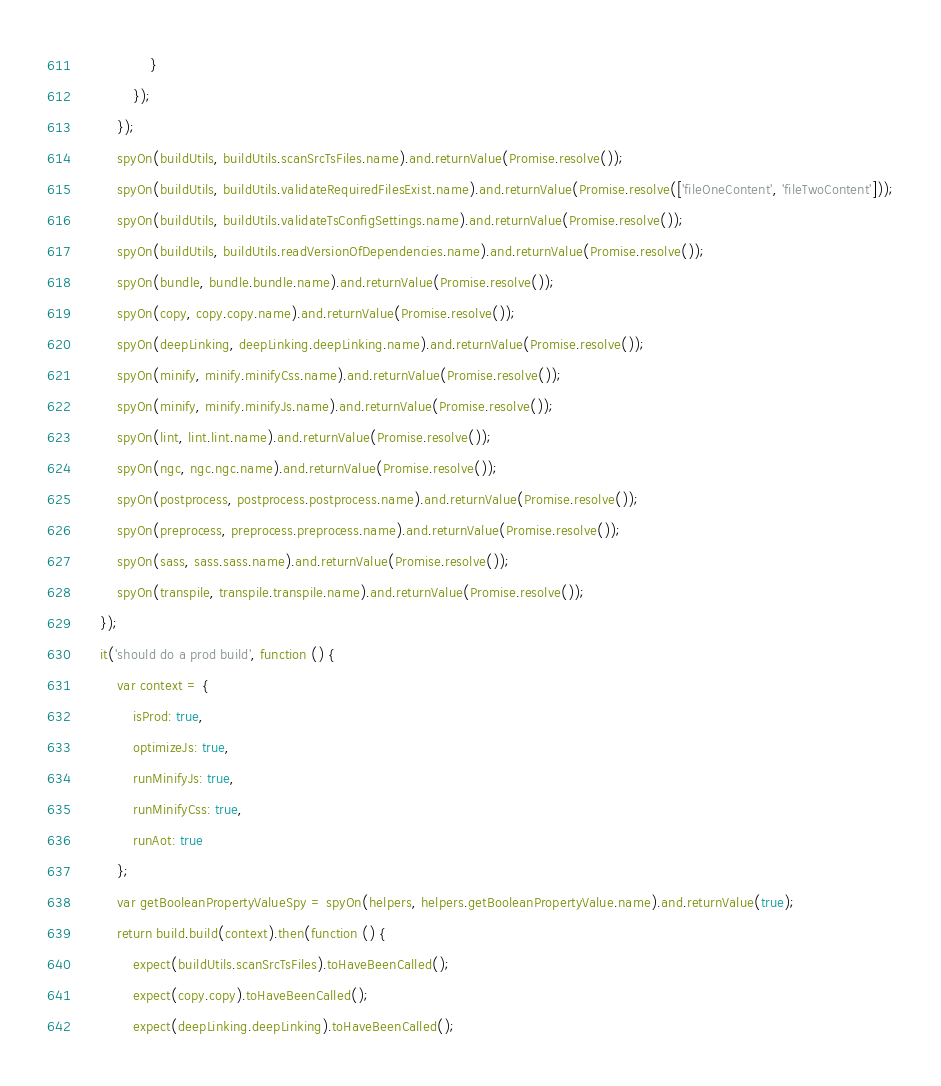Convert code to text. <code><loc_0><loc_0><loc_500><loc_500><_JavaScript_>                }
            });
        });
        spyOn(buildUtils, buildUtils.scanSrcTsFiles.name).and.returnValue(Promise.resolve());
        spyOn(buildUtils, buildUtils.validateRequiredFilesExist.name).and.returnValue(Promise.resolve(['fileOneContent', 'fileTwoContent']));
        spyOn(buildUtils, buildUtils.validateTsConfigSettings.name).and.returnValue(Promise.resolve());
        spyOn(buildUtils, buildUtils.readVersionOfDependencies.name).and.returnValue(Promise.resolve());
        spyOn(bundle, bundle.bundle.name).and.returnValue(Promise.resolve());
        spyOn(copy, copy.copy.name).and.returnValue(Promise.resolve());
        spyOn(deepLinking, deepLinking.deepLinking.name).and.returnValue(Promise.resolve());
        spyOn(minify, minify.minifyCss.name).and.returnValue(Promise.resolve());
        spyOn(minify, minify.minifyJs.name).and.returnValue(Promise.resolve());
        spyOn(lint, lint.lint.name).and.returnValue(Promise.resolve());
        spyOn(ngc, ngc.ngc.name).and.returnValue(Promise.resolve());
        spyOn(postprocess, postprocess.postprocess.name).and.returnValue(Promise.resolve());
        spyOn(preprocess, preprocess.preprocess.name).and.returnValue(Promise.resolve());
        spyOn(sass, sass.sass.name).and.returnValue(Promise.resolve());
        spyOn(transpile, transpile.transpile.name).and.returnValue(Promise.resolve());
    });
    it('should do a prod build', function () {
        var context = {
            isProd: true,
            optimizeJs: true,
            runMinifyJs: true,
            runMinifyCss: true,
            runAot: true
        };
        var getBooleanPropertyValueSpy = spyOn(helpers, helpers.getBooleanPropertyValue.name).and.returnValue(true);
        return build.build(context).then(function () {
            expect(buildUtils.scanSrcTsFiles).toHaveBeenCalled();
            expect(copy.copy).toHaveBeenCalled();
            expect(deepLinking.deepLinking).toHaveBeenCalled();</code> 